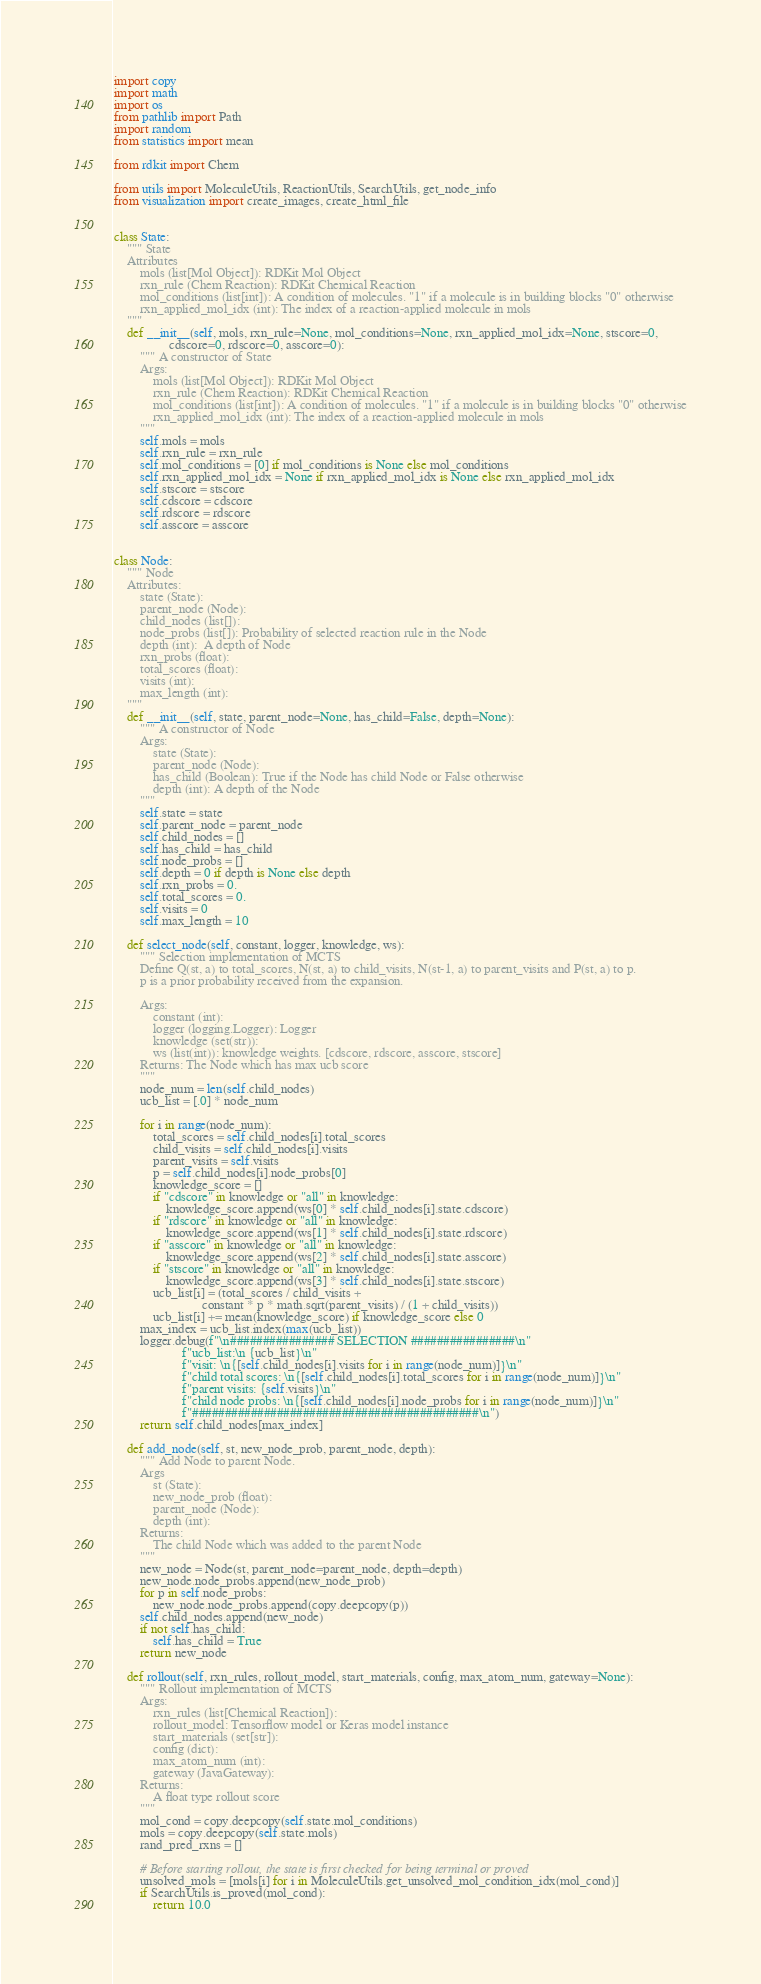<code> <loc_0><loc_0><loc_500><loc_500><_Python_>import copy
import math
import os
from pathlib import Path
import random
from statistics import mean

from rdkit import Chem

from utils import MoleculeUtils, ReactionUtils, SearchUtils, get_node_info
from visualization import create_images, create_html_file


class State:
    """ State
    Attributes
        mols (list[Mol Object]): RDKit Mol Object
        rxn_rule (Chem Reaction): RDKit Chemical Reaction
        mol_conditions (list[int]): A condition of molecules. "1" if a molecule is in building blocks "0" otherwise
        rxn_applied_mol_idx (int): The index of a reaction-applied molecule in mols
    """
    def __init__(self, mols, rxn_rule=None, mol_conditions=None, rxn_applied_mol_idx=None, stscore=0,
                 cdscore=0, rdscore=0, asscore=0):
        """ A constructor of State
        Args:
            mols (list[Mol Object]): RDKit Mol Object
            rxn_rule (Chem Reaction): RDKit Chemical Reaction
            mol_conditions (list[int]): A condition of molecules. "1" if a molecule is in building blocks "0" otherwise
            rxn_applied_mol_idx (int): The index of a reaction-applied molecule in mols
        """
        self.mols = mols
        self.rxn_rule = rxn_rule
        self.mol_conditions = [0] if mol_conditions is None else mol_conditions
        self.rxn_applied_mol_idx = None if rxn_applied_mol_idx is None else rxn_applied_mol_idx
        self.stscore = stscore
        self.cdscore = cdscore
        self.rdscore = rdscore
        self.asscore = asscore


class Node:
    """ Node
    Attributes:
        state (State):
        parent_node (Node):
        child_nodes (list[]):
        node_probs (list[]): Probability of selected reaction rule in the Node
        depth (int):  A depth of Node
        rxn_probs (float):
        total_scores (float):
        visits (int):
        max_length (int):
    """
    def __init__(self, state, parent_node=None, has_child=False, depth=None):
        """ A constructor of Node
        Args:
            state (State):
            parent_node (Node):
            has_child (Boolean): True if the Node has child Node or False otherwise
            depth (int): A depth of the Node
        """
        self.state = state
        self.parent_node = parent_node
        self.child_nodes = []
        self.has_child = has_child
        self.node_probs = []
        self.depth = 0 if depth is None else depth
        self.rxn_probs = 0.
        self.total_scores = 0.
        self.visits = 0
        self.max_length = 10

    def select_node(self, constant, logger, knowledge, ws):
        """ Selection implementation of MCTS
        Define Q(st, a) to total_scores, N(st, a) to child_visits, N(st-1, a) to parent_visits and P(st, a) to p.
        p is a prior probability received from the expansion.

        Args:
            constant (int):
            logger (logging.Logger): Logger
            knowledge (set(str)):
            ws (list(int)): knowledge weights. [cdscore, rdscore, asscore, stscore]
        Returns: The Node which has max ucb score
        """
        node_num = len(self.child_nodes)
        ucb_list = [.0] * node_num

        for i in range(node_num):
            total_scores = self.child_nodes[i].total_scores
            child_visits = self.child_nodes[i].visits
            parent_visits = self.visits
            p = self.child_nodes[i].node_probs[0]
            knowledge_score = []
            if "cdscore" in knowledge or "all" in knowledge:
                knowledge_score.append(ws[0] * self.child_nodes[i].state.cdscore)
            if "rdscore" in knowledge or "all" in knowledge:
                knowledge_score.append(ws[1] * self.child_nodes[i].state.rdscore)
            if "asscore" in knowledge or "all" in knowledge:
                knowledge_score.append(ws[2] * self.child_nodes[i].state.asscore)
            if "stscore" in knowledge or "all" in knowledge:
                knowledge_score.append(ws[3] * self.child_nodes[i].state.stscore)
            ucb_list[i] = (total_scores / child_visits +
                           constant * p * math.sqrt(parent_visits) / (1 + child_visits))
            ucb_list[i] += mean(knowledge_score) if knowledge_score else 0
        max_index = ucb_list.index(max(ucb_list))
        logger.debug(f"\n################ SELECTION ################\n"
                     f"ucb_list:\n {ucb_list}\n"
                     f"visit: \n{[self.child_nodes[i].visits for i in range(node_num)]}\n"
                     f"child total scores: \n{[self.child_nodes[i].total_scores for i in range(node_num)]}\n"
                     f"parent visits: {self.visits}\n"
                     f"child node probs: \n{[self.child_nodes[i].node_probs for i in range(node_num)]}\n"
                     f"############################################\n")
        return self.child_nodes[max_index]

    def add_node(self, st, new_node_prob, parent_node, depth):
        """ Add Node to parent Node.
        Args
            st (State):
            new_node_prob (float):
            parent_node (Node):
            depth (int):
        Returns:
            The child Node which was added to the parent Node
        """
        new_node = Node(st, parent_node=parent_node, depth=depth)
        new_node.node_probs.append(new_node_prob)
        for p in self.node_probs:
            new_node.node_probs.append(copy.deepcopy(p))
        self.child_nodes.append(new_node)
        if not self.has_child:
            self.has_child = True
        return new_node

    def rollout(self, rxn_rules, rollout_model, start_materials, config, max_atom_num, gateway=None):
        """ Rollout implementation of MCTS
        Args:
            rxn_rules (list[Chemical Reaction]):
            rollout_model: Tensorflow model or Keras model instance
            start_materials (set[str]):
            config (dict):
            max_atom_num (int):
            gateway (JavaGateway):
        Returns:
            A float type rollout score
        """
        mol_cond = copy.deepcopy(self.state.mol_conditions)
        mols = copy.deepcopy(self.state.mols)
        rand_pred_rxns = []

        # Before starting rollout, the state is first checked for being terminal or proved
        unsolved_mols = [mols[i] for i in MoleculeUtils.get_unsolved_mol_condition_idx(mol_cond)]
        if SearchUtils.is_proved(mol_cond):
            return 10.0</code> 